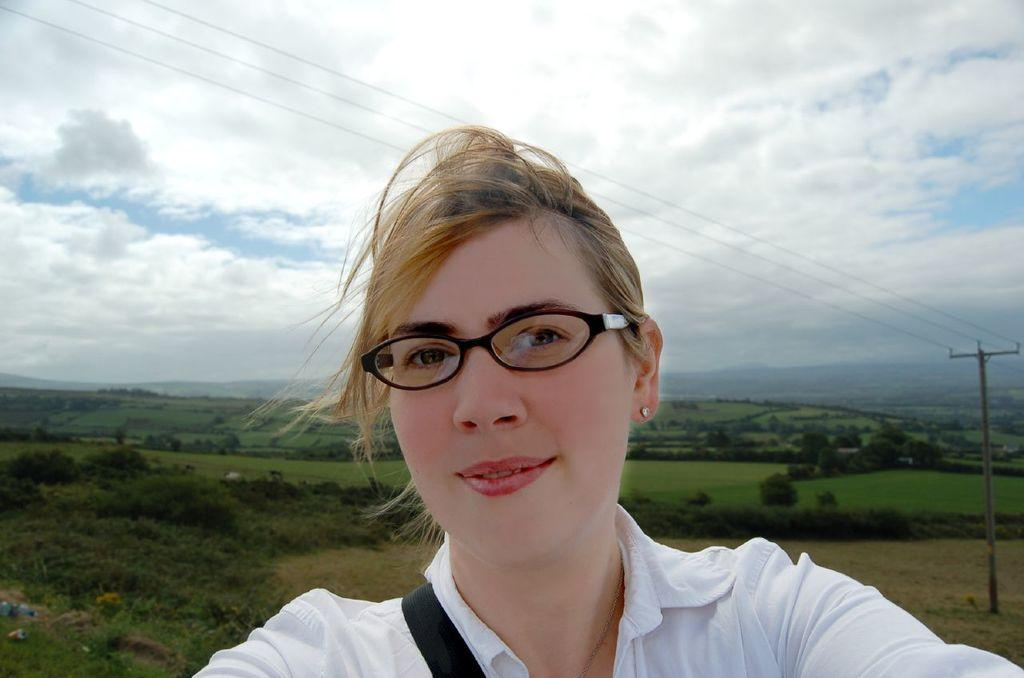Who is the main subject in the foreground of the image? There is a woman in the foreground of the image. What can be seen in the background of the image? There are trees, grass, a pole, and wires in the background of the image. What is visible at the top of the image? The sky is visible at the top of the image. What type of drink is being served at the edge of the image? There is no drink or edge present in the image; it features a woman in the foreground and various elements in the background. 